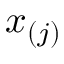Convert formula to latex. <formula><loc_0><loc_0><loc_500><loc_500>x _ { ( j ) }</formula> 